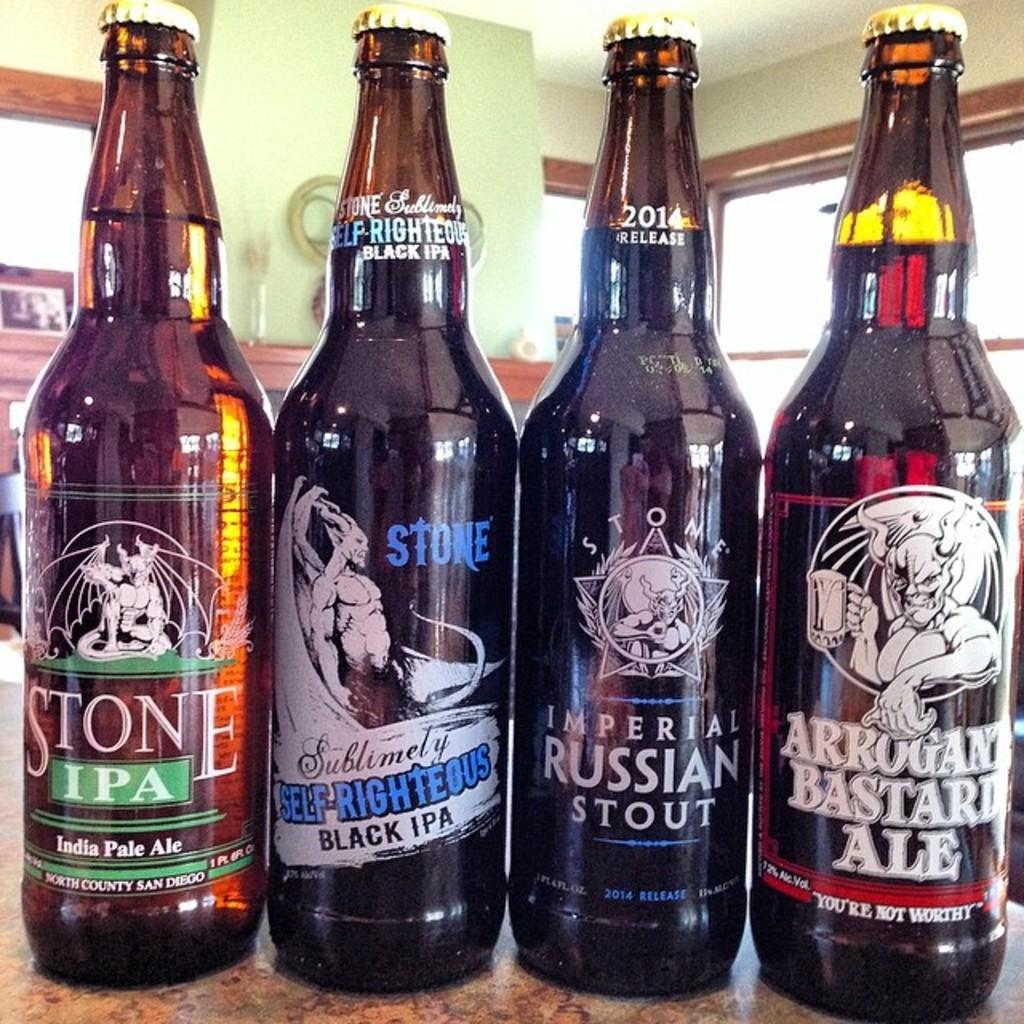<image>
Share a concise interpretation of the image provided. Four bottles of various beers which one is Imperial Russian Stout. 